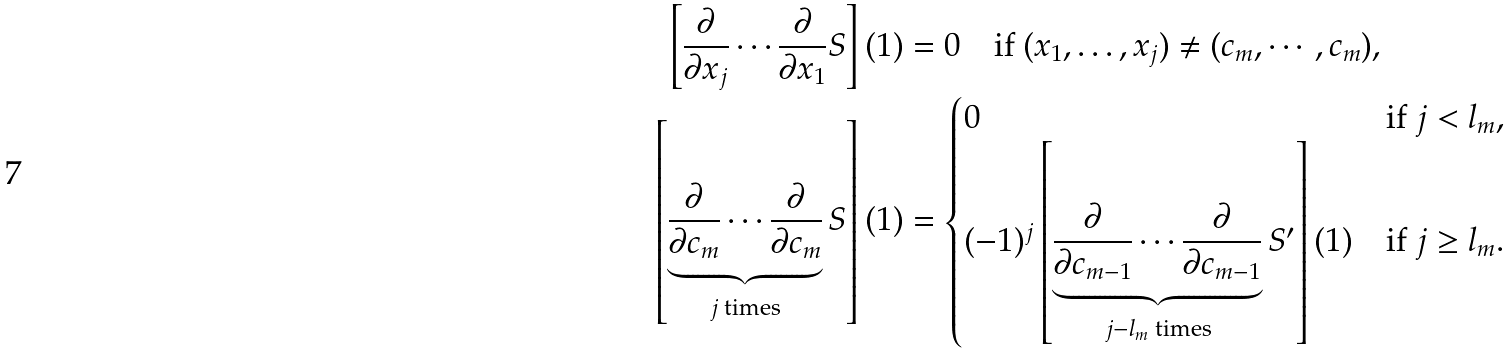Convert formula to latex. <formula><loc_0><loc_0><loc_500><loc_500>\left [ \frac { \partial } { \partial x _ { j } } \cdots \frac { \partial } { \partial x _ { 1 } } S \right ] ( 1 ) & = 0 \quad \text {if } ( x _ { 1 } , \dots , x _ { j } ) \neq ( c _ { m } , \cdots , c _ { m } ) , \\ \left [ \underbrace { \frac { \partial } { \partial c _ { m } } \cdots \frac { \partial } { \partial c _ { m } } } _ { j \text { times} } S \right ] ( 1 ) & = \begin{cases} 0 & \text {if } j < l _ { m } , \\ ( - 1 ) ^ { j } \left [ \underbrace { \frac { \partial } { \partial c _ { m - 1 } } \cdots \frac { \partial } { \partial c _ { m - 1 } } } _ { j - l _ { m } \text { times} } S ^ { \prime } \right ] ( 1 ) & \text {if } j \geq l _ { m } . \end{cases}</formula> 